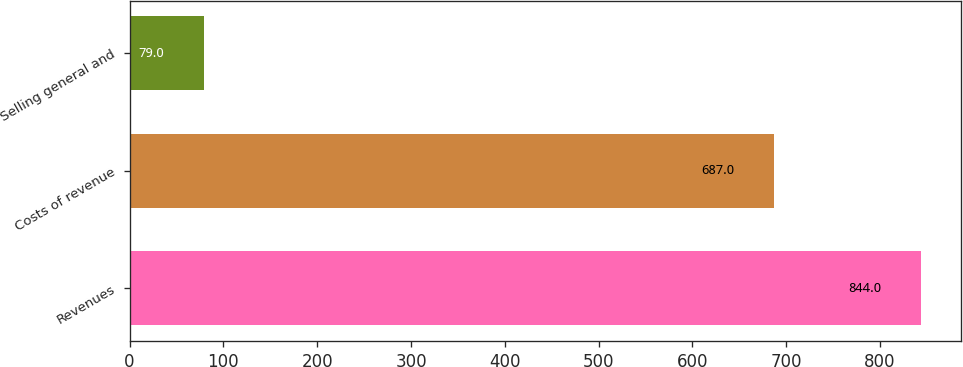Convert chart to OTSL. <chart><loc_0><loc_0><loc_500><loc_500><bar_chart><fcel>Revenues<fcel>Costs of revenue<fcel>Selling general and<nl><fcel>844<fcel>687<fcel>79<nl></chart> 